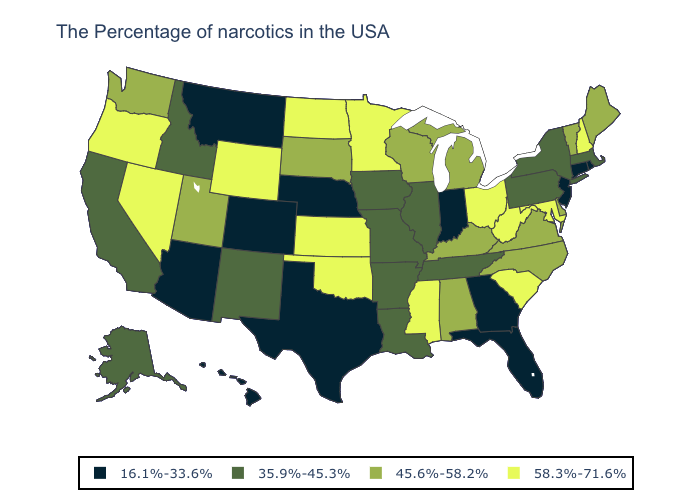What is the highest value in the USA?
Quick response, please. 58.3%-71.6%. Does the first symbol in the legend represent the smallest category?
Concise answer only. Yes. What is the value of Missouri?
Quick response, please. 35.9%-45.3%. What is the value of Oklahoma?
Write a very short answer. 58.3%-71.6%. Does Vermont have the lowest value in the Northeast?
Concise answer only. No. Which states hav the highest value in the MidWest?
Write a very short answer. Ohio, Minnesota, Kansas, North Dakota. Is the legend a continuous bar?
Quick response, please. No. What is the value of Maryland?
Quick response, please. 58.3%-71.6%. Is the legend a continuous bar?
Write a very short answer. No. How many symbols are there in the legend?
Answer briefly. 4. Name the states that have a value in the range 58.3%-71.6%?
Short answer required. New Hampshire, Maryland, South Carolina, West Virginia, Ohio, Mississippi, Minnesota, Kansas, Oklahoma, North Dakota, Wyoming, Nevada, Oregon. Name the states that have a value in the range 58.3%-71.6%?
Short answer required. New Hampshire, Maryland, South Carolina, West Virginia, Ohio, Mississippi, Minnesota, Kansas, Oklahoma, North Dakota, Wyoming, Nevada, Oregon. What is the value of Ohio?
Quick response, please. 58.3%-71.6%. Among the states that border Vermont , does New Hampshire have the highest value?
Give a very brief answer. Yes. What is the lowest value in states that border Louisiana?
Quick response, please. 16.1%-33.6%. 